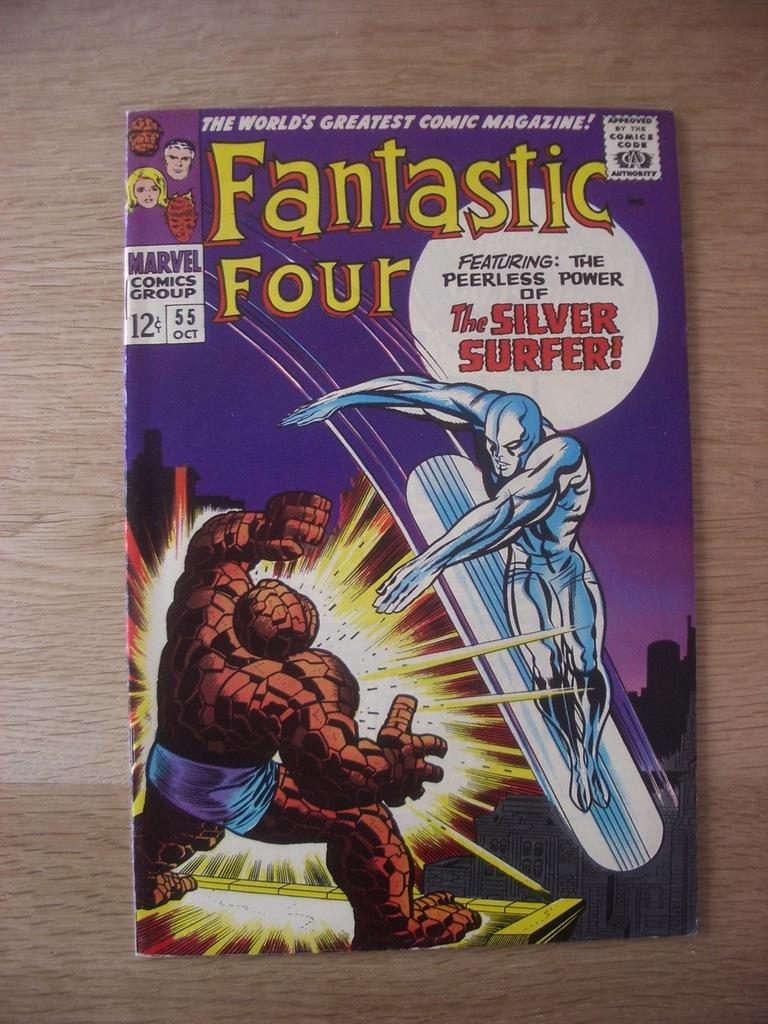Provide a one-sentence caption for the provided image. A copy of the Fantastic Four magazine featuring the Silver Surfer. 